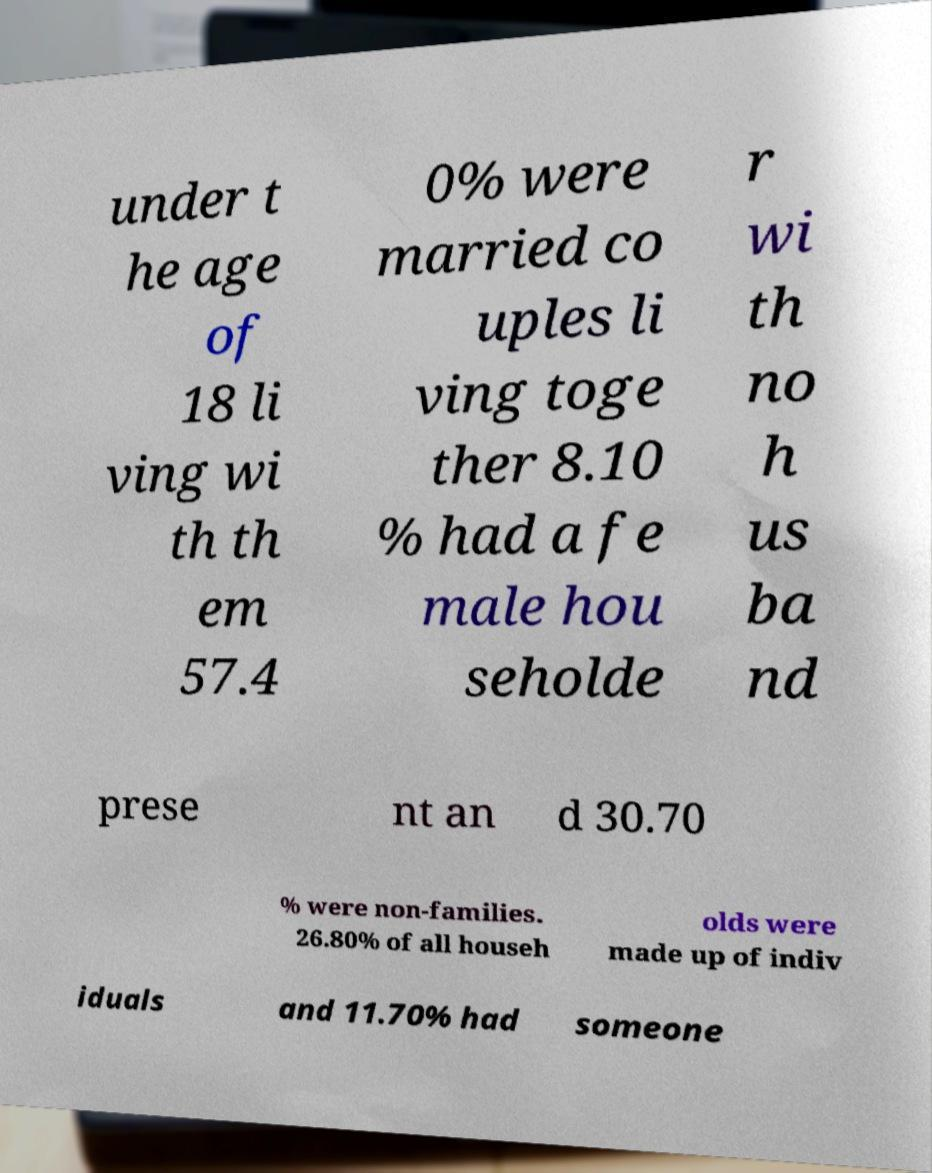Please identify and transcribe the text found in this image. under t he age of 18 li ving wi th th em 57.4 0% were married co uples li ving toge ther 8.10 % had a fe male hou seholde r wi th no h us ba nd prese nt an d 30.70 % were non-families. 26.80% of all househ olds were made up of indiv iduals and 11.70% had someone 